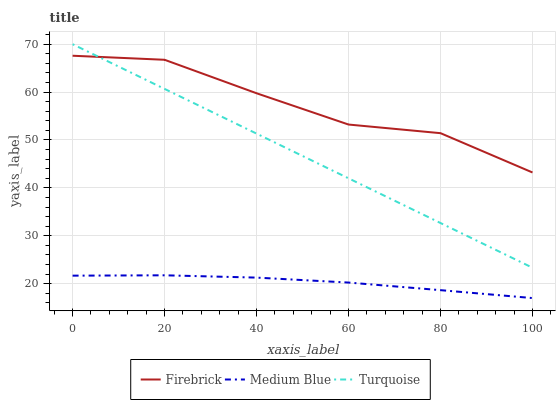Does Turquoise have the minimum area under the curve?
Answer yes or no. No. Does Turquoise have the maximum area under the curve?
Answer yes or no. No. Is Medium Blue the smoothest?
Answer yes or no. No. Is Medium Blue the roughest?
Answer yes or no. No. Does Turquoise have the lowest value?
Answer yes or no. No. Does Medium Blue have the highest value?
Answer yes or no. No. Is Medium Blue less than Firebrick?
Answer yes or no. Yes. Is Turquoise greater than Medium Blue?
Answer yes or no. Yes. Does Medium Blue intersect Firebrick?
Answer yes or no. No. 